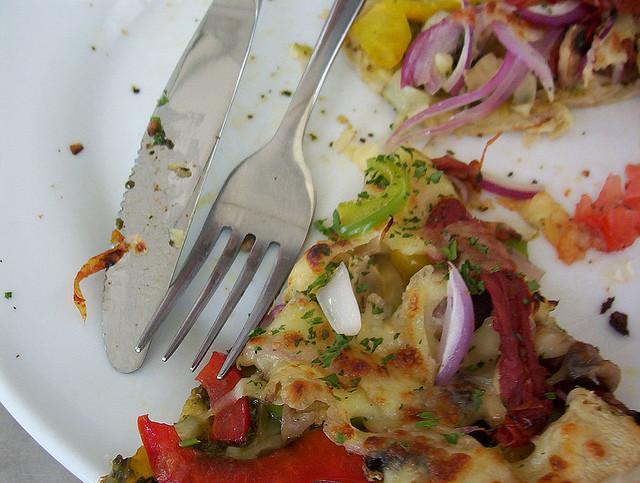How many pizzas are there?
Give a very brief answer. 2. 